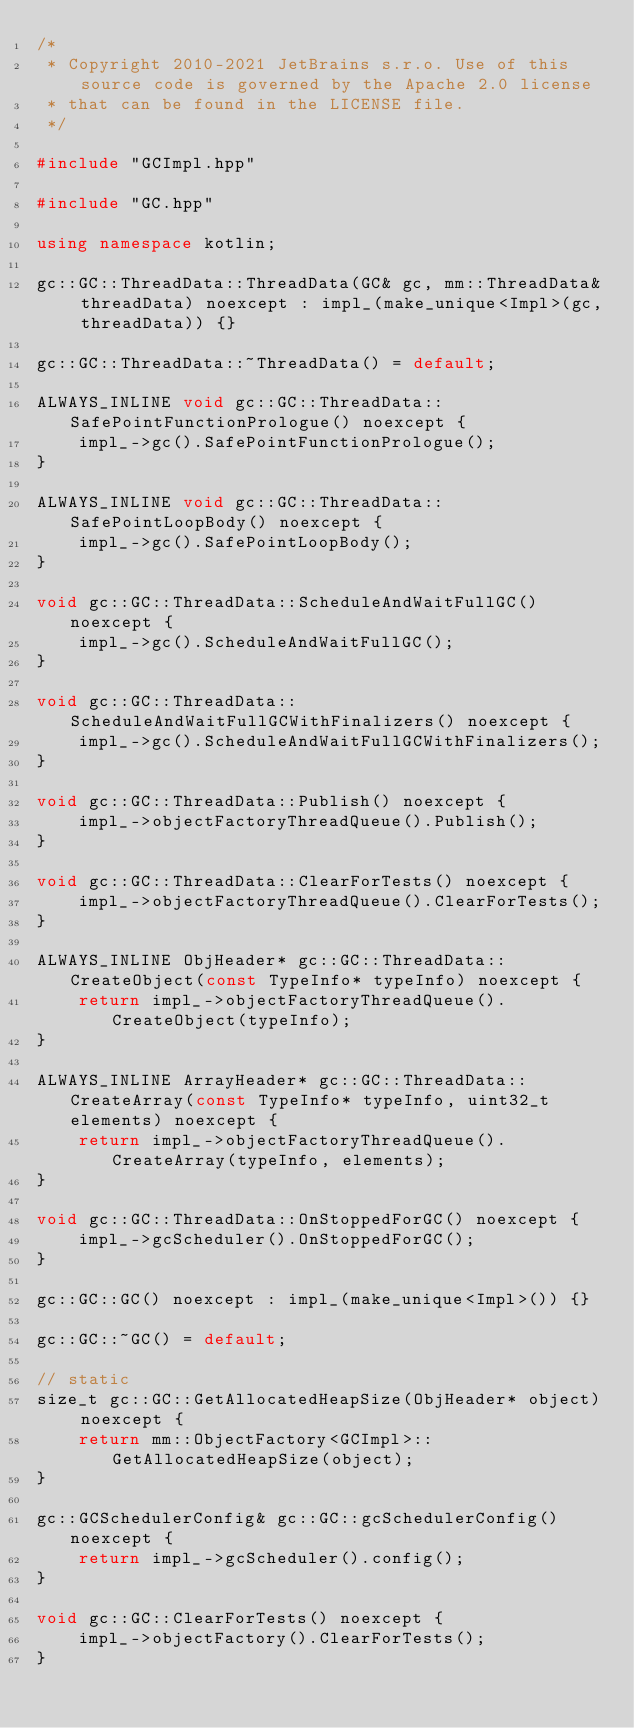Convert code to text. <code><loc_0><loc_0><loc_500><loc_500><_C++_>/*
 * Copyright 2010-2021 JetBrains s.r.o. Use of this source code is governed by the Apache 2.0 license
 * that can be found in the LICENSE file.
 */

#include "GCImpl.hpp"

#include "GC.hpp"

using namespace kotlin;

gc::GC::ThreadData::ThreadData(GC& gc, mm::ThreadData& threadData) noexcept : impl_(make_unique<Impl>(gc, threadData)) {}

gc::GC::ThreadData::~ThreadData() = default;

ALWAYS_INLINE void gc::GC::ThreadData::SafePointFunctionPrologue() noexcept {
    impl_->gc().SafePointFunctionPrologue();
}

ALWAYS_INLINE void gc::GC::ThreadData::SafePointLoopBody() noexcept {
    impl_->gc().SafePointLoopBody();
}

void gc::GC::ThreadData::ScheduleAndWaitFullGC() noexcept {
    impl_->gc().ScheduleAndWaitFullGC();
}

void gc::GC::ThreadData::ScheduleAndWaitFullGCWithFinalizers() noexcept {
    impl_->gc().ScheduleAndWaitFullGCWithFinalizers();
}

void gc::GC::ThreadData::Publish() noexcept {
    impl_->objectFactoryThreadQueue().Publish();
}

void gc::GC::ThreadData::ClearForTests() noexcept {
    impl_->objectFactoryThreadQueue().ClearForTests();
}

ALWAYS_INLINE ObjHeader* gc::GC::ThreadData::CreateObject(const TypeInfo* typeInfo) noexcept {
    return impl_->objectFactoryThreadQueue().CreateObject(typeInfo);
}

ALWAYS_INLINE ArrayHeader* gc::GC::ThreadData::CreateArray(const TypeInfo* typeInfo, uint32_t elements) noexcept {
    return impl_->objectFactoryThreadQueue().CreateArray(typeInfo, elements);
}

void gc::GC::ThreadData::OnStoppedForGC() noexcept {
    impl_->gcScheduler().OnStoppedForGC();
}

gc::GC::GC() noexcept : impl_(make_unique<Impl>()) {}

gc::GC::~GC() = default;

// static
size_t gc::GC::GetAllocatedHeapSize(ObjHeader* object) noexcept {
    return mm::ObjectFactory<GCImpl>::GetAllocatedHeapSize(object);
}

gc::GCSchedulerConfig& gc::GC::gcSchedulerConfig() noexcept {
    return impl_->gcScheduler().config();
}

void gc::GC::ClearForTests() noexcept {
    impl_->objectFactory().ClearForTests();
}
</code> 